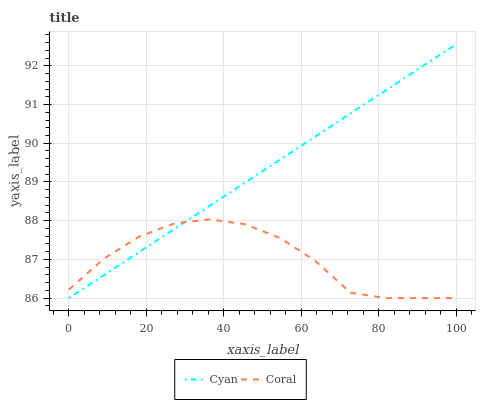Does Coral have the minimum area under the curve?
Answer yes or no. Yes. Does Cyan have the maximum area under the curve?
Answer yes or no. Yes. Does Coral have the maximum area under the curve?
Answer yes or no. No. Is Cyan the smoothest?
Answer yes or no. Yes. Is Coral the roughest?
Answer yes or no. Yes. Is Coral the smoothest?
Answer yes or no. No. Does Cyan have the lowest value?
Answer yes or no. Yes. Does Cyan have the highest value?
Answer yes or no. Yes. Does Coral have the highest value?
Answer yes or no. No. Does Cyan intersect Coral?
Answer yes or no. Yes. Is Cyan less than Coral?
Answer yes or no. No. Is Cyan greater than Coral?
Answer yes or no. No. 